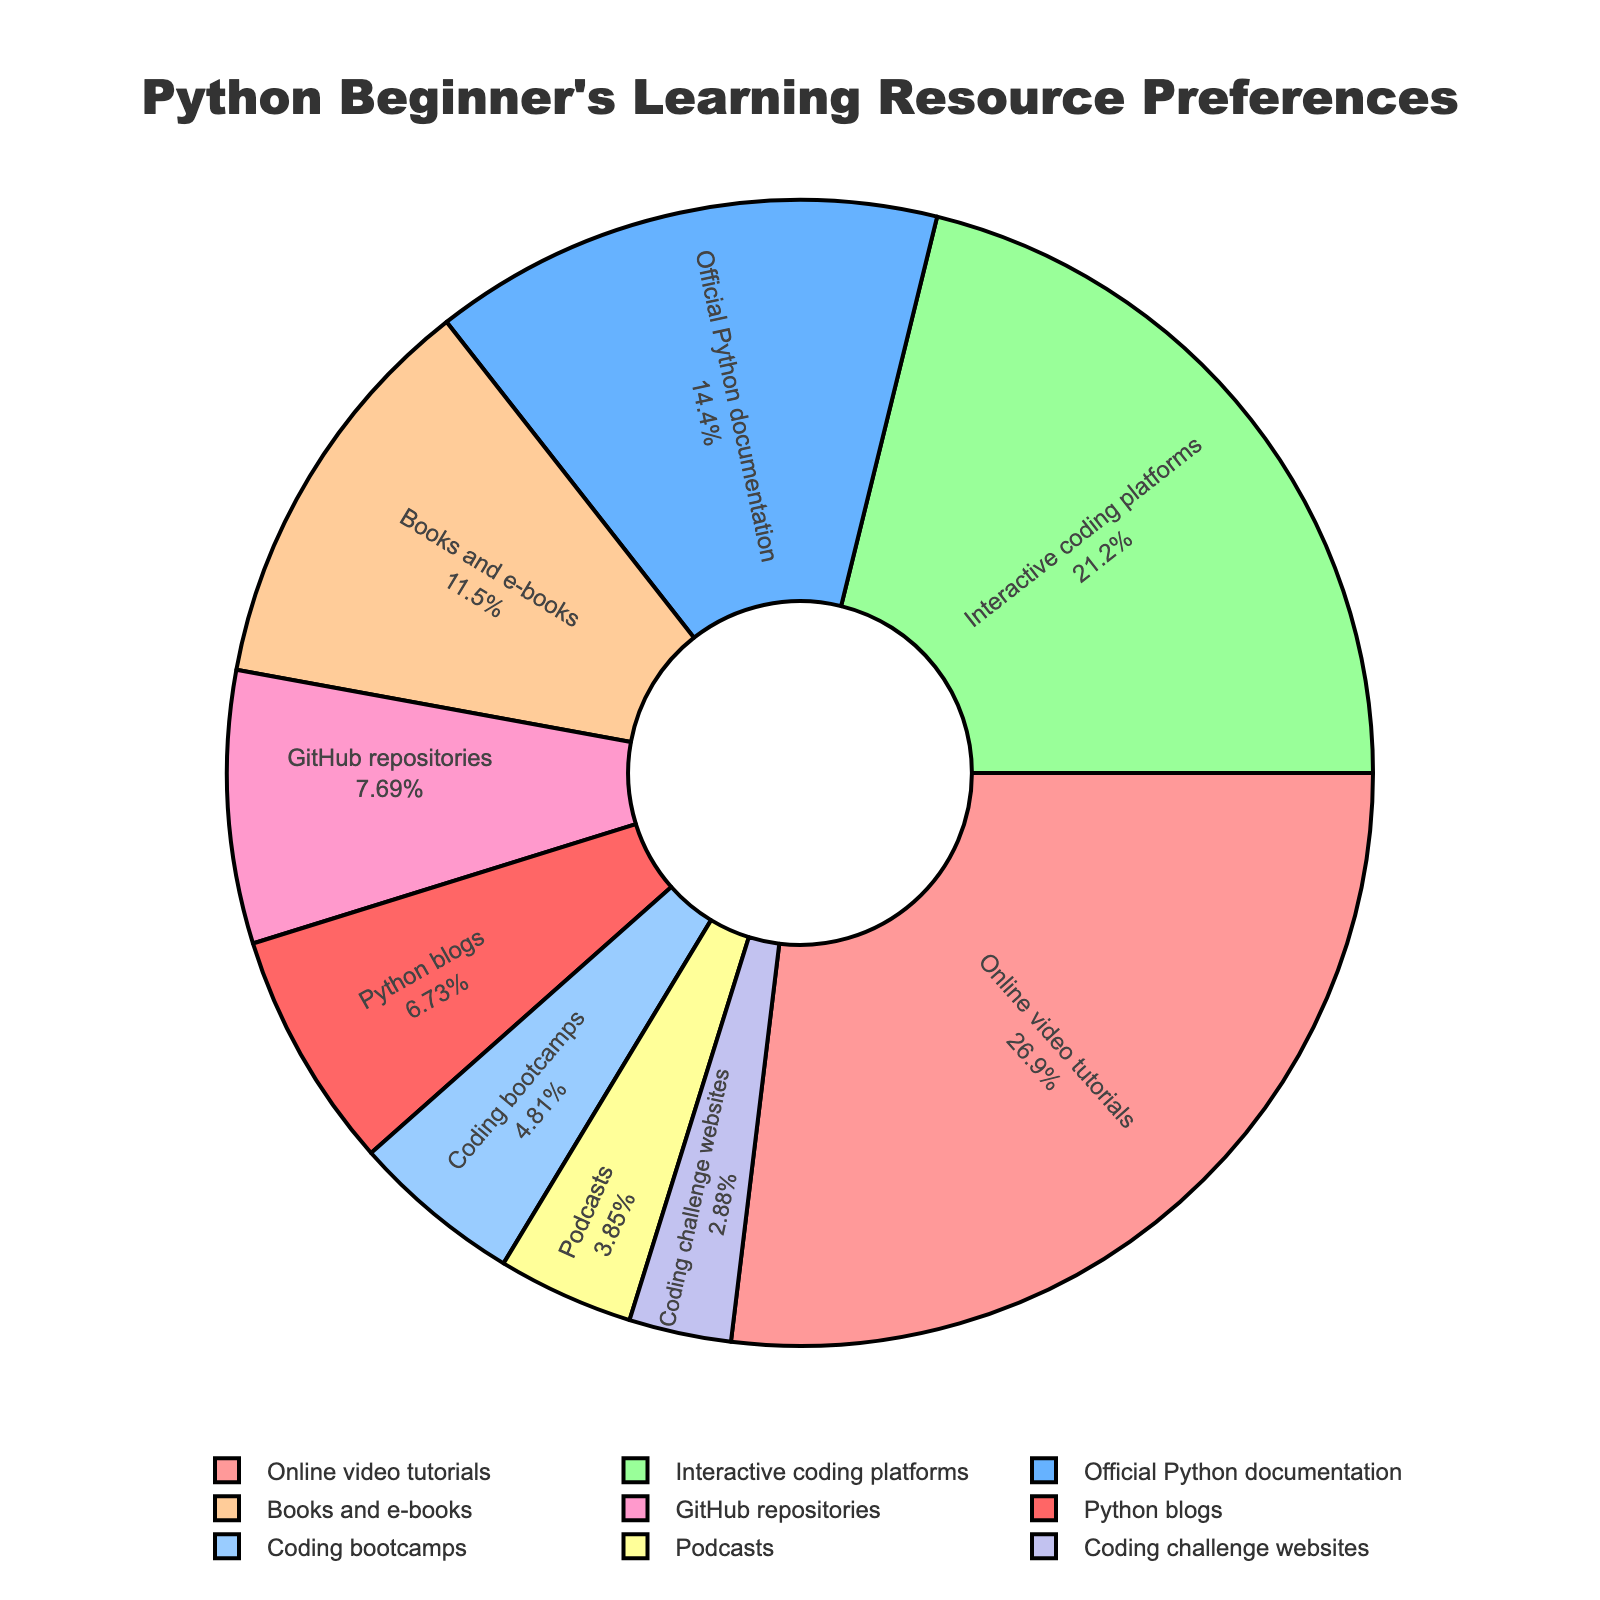What's the most preferred learning resource for Python beginners according to the chart? The largest section of the pie chart represents the most preferred learning resource. It shows "Online video tutorials" with 28%.
Answer: Online video tutorials Which learning resource has the smallest percentage in the chart? The smallest section of the pie chart represents the least preferred resource, which is "Coding challenge websites" at 3%.
Answer: Coding challenge websites What is the combined percentage of "Books and e-books" and "GitHub repositories"? The sections for "Books and e-books" and "GitHub repositories" are 12% and 8%, respectively. Summing these percentages, 12% + 8% = 20%.
Answer: 20% Which is more popular, "Interactive coding platforms" or "Official Python documentation"? Comparing the pie sections for "Interactive coding platforms" and "Official Python documentation", 22% > 15%, so "Interactive coding platforms" is more popular.
Answer: Interactive coding platforms By how much does the percentage of "Online video tutorials" exceed "Books and e-books"? The percentage for "Online video tutorials" is 28% and for "Books and e-books" is 12%. The difference is 28% - 12% = 16%.
Answer: 16% How many resources have a percentage equal to or less than 8%? The sections equal to or less than 8% are "GitHub repositories" (8%), "Coding bootcamps" (5%), "Podcasts" (4%), and "Coding challenge websites" (3%). There are 4 of these resources.
Answer: 4 Compare the combined percentage of "Podcasts" and "Python blogs" to the percentage of "Books and e-books". Which is higher and by how much? The combined percentage for "Podcasts" and "Python blogs" is 4% + 7% = 11%. The percentage for "Books and e-books" is 12%. Comparing 12% to 11%, "Books and e-books" is higher by 1%.
Answer: Books and e-books by 1% What percentage of the resources fall into the "Other" category (less than 10%)? Counting the sections less than 10%: "GitHub repositories" (8%), "Coding bootcamps" (5%), "Podcasts" (4%), "Python blogs" (7%), "Coding challenge websites" (3%). Summing these, 8% + 5% + 4% + 7% + 3% = 27%.
Answer: 27% Out of "Online video tutorials", "Interactive coding platforms", and "Official Python documentation", which one has the medium value and what is it? Listing the values: "Online video tutorials" (28%), "Interactive coding platforms" (22%), "Official Python documentation" (15%), the medium value is 22%.
Answer: Interactive coding platforms at 22% 